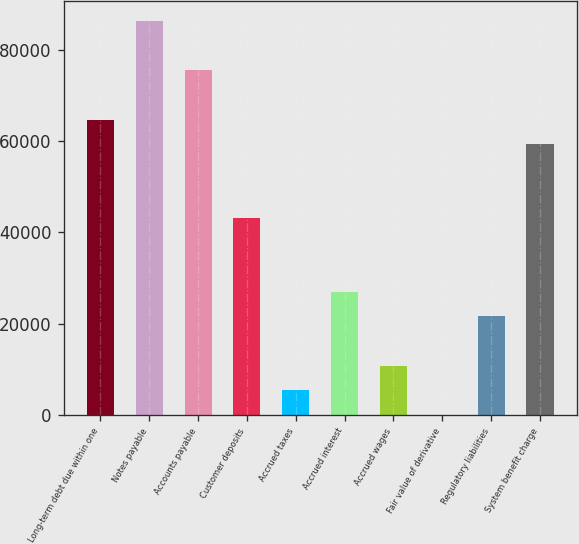<chart> <loc_0><loc_0><loc_500><loc_500><bar_chart><fcel>Long-term debt due within one<fcel>Notes payable<fcel>Accounts payable<fcel>Customer deposits<fcel>Accrued taxes<fcel>Accrued interest<fcel>Accrued wages<fcel>Fair value of derivative<fcel>Regulatory liabilities<fcel>System benefit charge<nl><fcel>64694<fcel>86242<fcel>75468<fcel>43146<fcel>5437<fcel>26985<fcel>10824<fcel>50<fcel>21598<fcel>59307<nl></chart> 